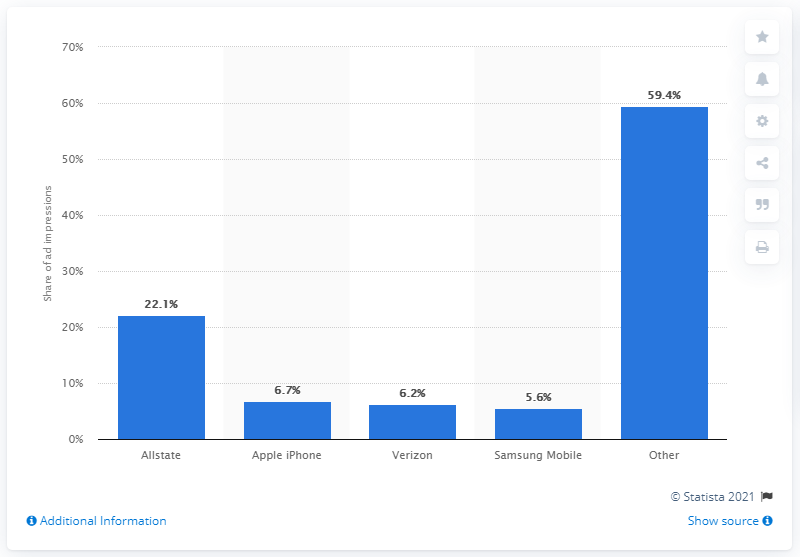Identify some key points in this picture. During the finals of the 2016 NBA season, Verizon attracted 6.7% of all TV ad impressions. 